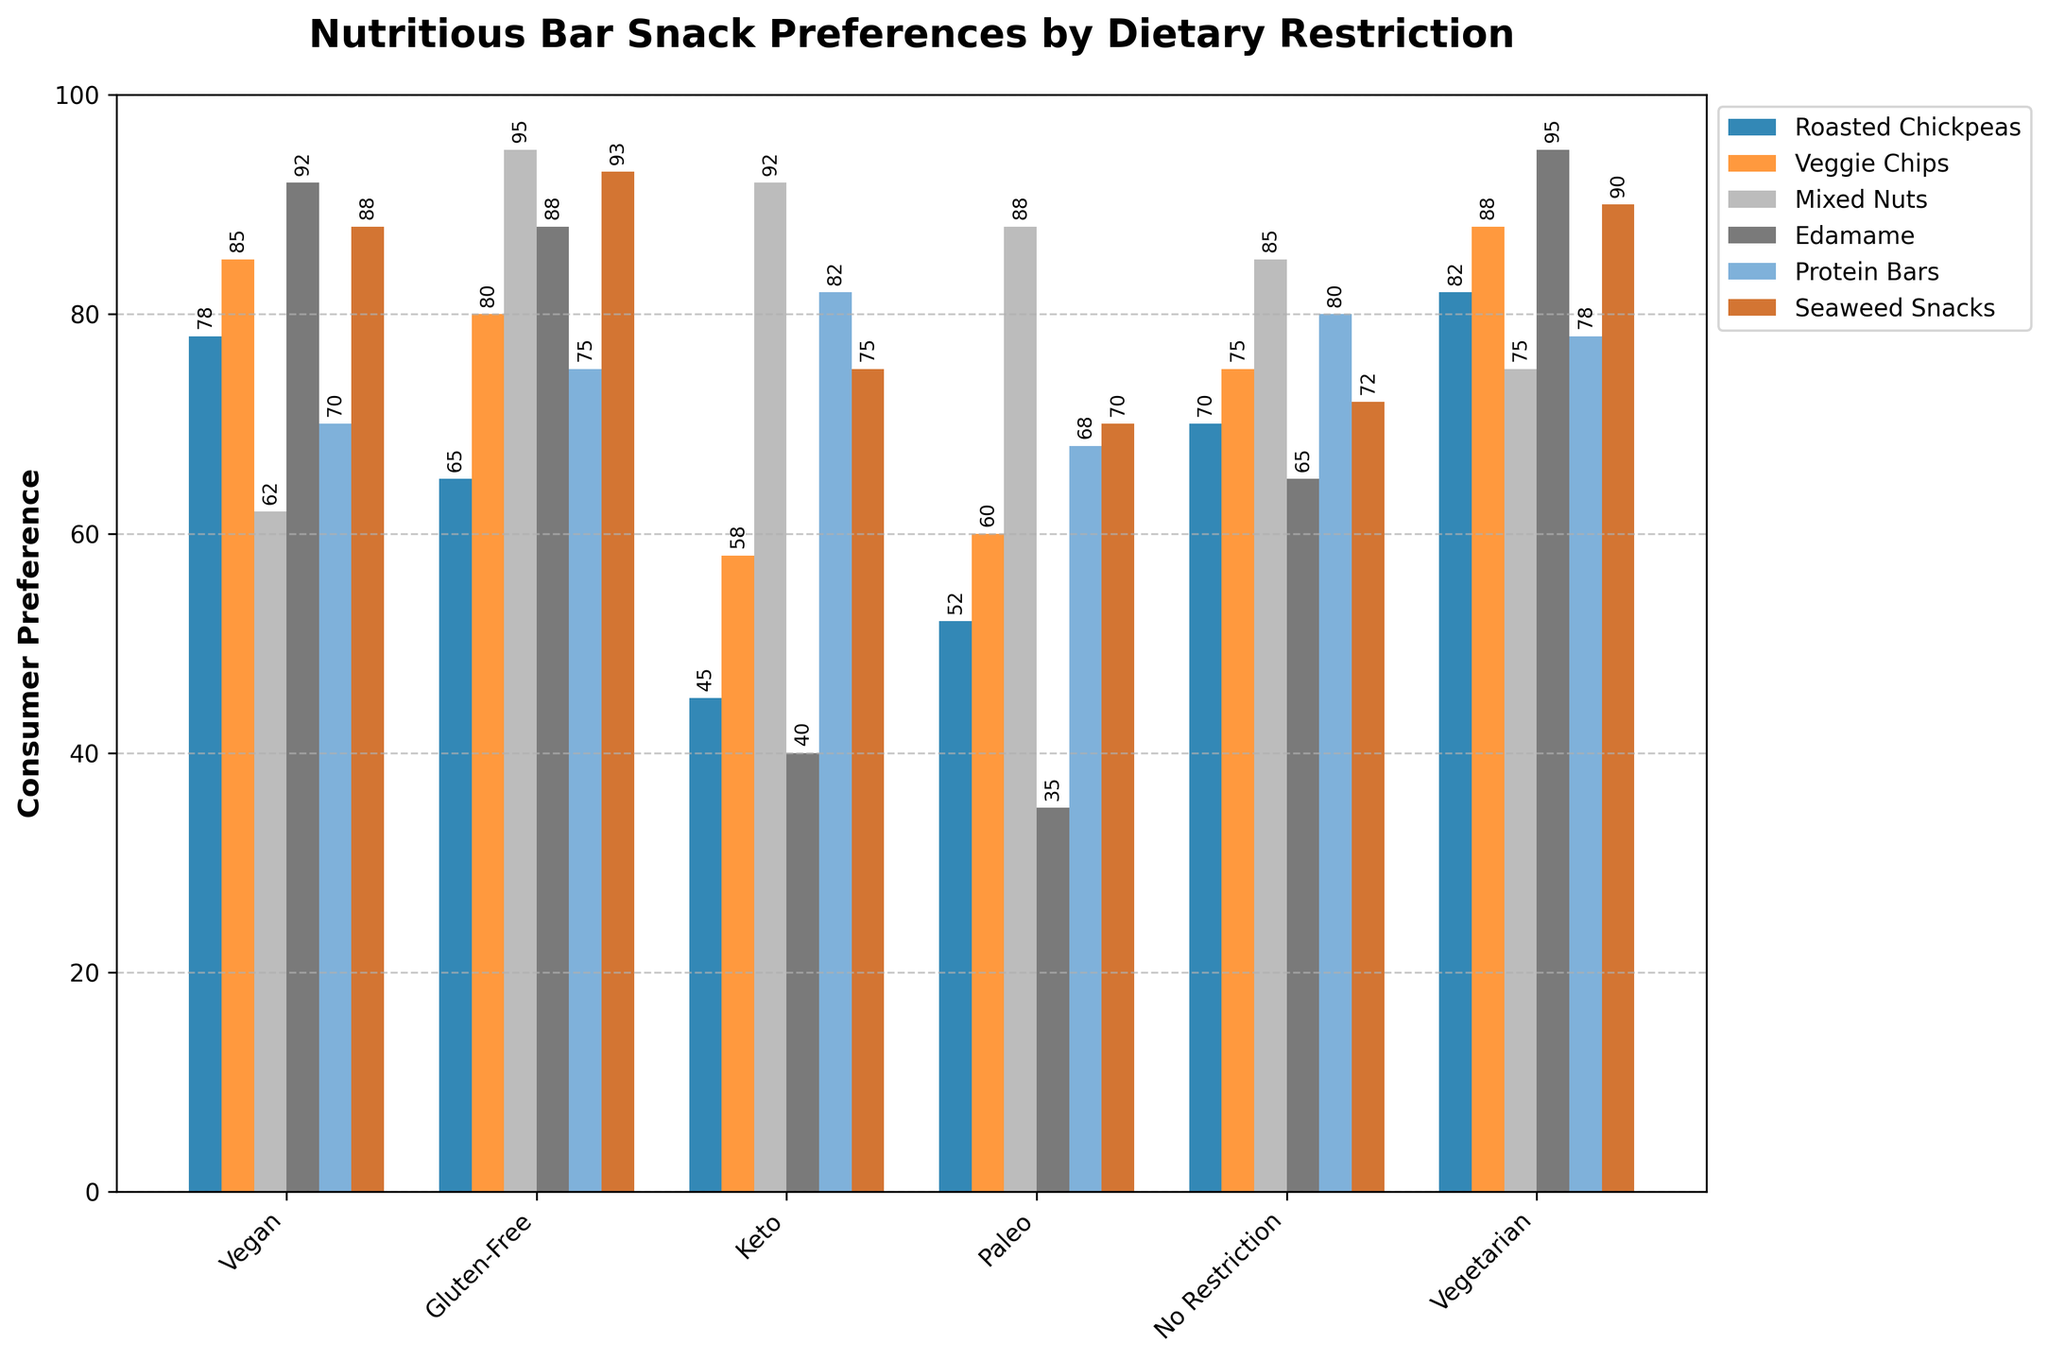What dietary restriction has the highest preference for Edamame? The heights of the bars for Edamame indicate consumer preference for each dietary restriction. The bar for 'Vegetarian' reaches the highest point on the y-axis.
Answer: Vegetarian Which snack has the highest consumer preference overall? Identify the highest bar across all snack types and dietary restrictions. The bar for Mixed Nuts under 'Gluten-Free' is the tallest.
Answer: Mixed Nuts How much higher is the preference for Seaweed Snacks compared to Protein Bars among people with no dietary restriction? Find and compare the heights of the bars for Seaweed Snacks and Protein Bars under 'No Restriction'. The value for Seaweed Snacks is 72, while Protein Bars is 80. Thus, Seaweed Snacks is 72 - 80 = -8 (8 less) than Protein Bars.
Answer: -8 What is the average consumer preference for Protein Bars across all dietary restrictions? Add the values for Protein Bars for all restrictions and divide by the number of restrictions: (70 + 75 + 82 + 68 + 80 + 78) / 6 = 75
Answer: 75 Which dietary restriction has the smallest range of preferences for all snack types? Calculate the range (max value - min value) for each dietary restriction. 'Paleo' shows 88-35=53, 'Keto' shows 92-40=52, and so on. The smallest range is 53 for Paleo.
Answer: Paleo Which snack is the least preferred by people following a keto diet? Look for the shortest bar in the Keto group. 'Edamame' has the lowest height at 40.
Answer: Edamame How does the preference for Roasted Chickpeas among vegans compare to that among vegetarians? Compare the heights of the bars for Roasted Chickpeas in the Vegan and Vegetarian groups. Vegan is 78 and Vegetarian is 82.
Answer: 78 vs 82 What is the total preference score for veggie chips across all dietary restrictions? Summing the values for Veggie Chips across all dietary restrictions: 85 + 80 + 58 + 60 + 75 + 88 = 446
Answer: 446 